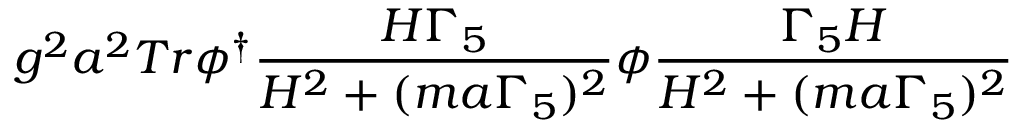Convert formula to latex. <formula><loc_0><loc_0><loc_500><loc_500>g ^ { 2 } a ^ { 2 } T r \phi ^ { \dagger } \frac { H \Gamma _ { 5 } } { H ^ { 2 } + ( m a \Gamma _ { 5 } ) ^ { 2 } } \phi \frac { \Gamma _ { 5 } H } { H ^ { 2 } + ( m a \Gamma _ { 5 } ) ^ { 2 } }</formula> 